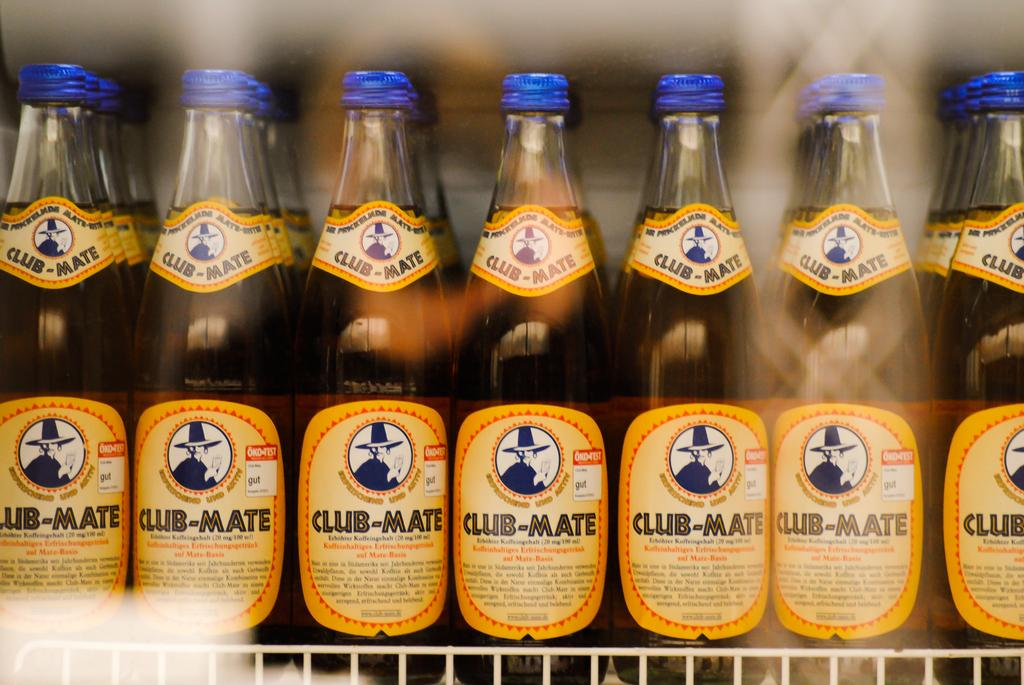<image>
Present a compact description of the photo's key features. Twenty one Club Mate beers on the shelf of a fridge in rows of seven and three columns. 